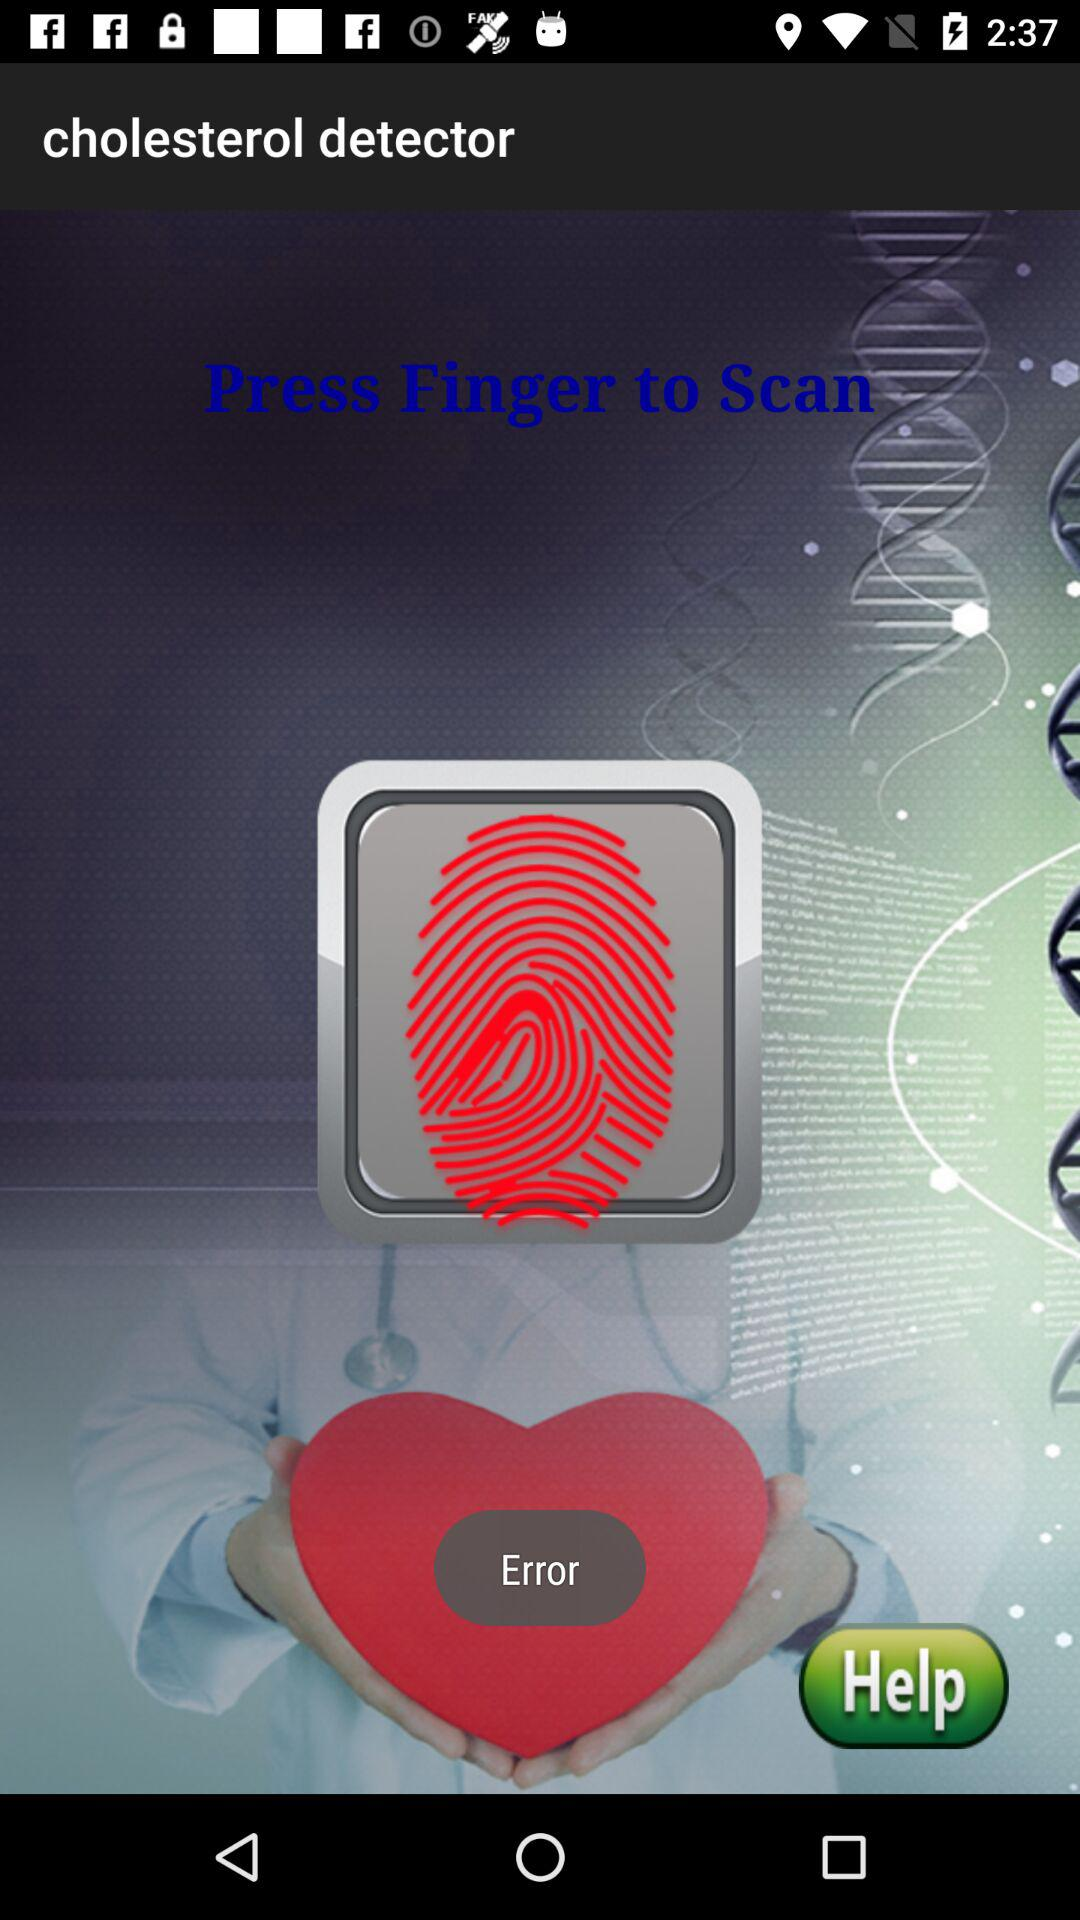What is the application name? The application name is "cholesterol detector". 